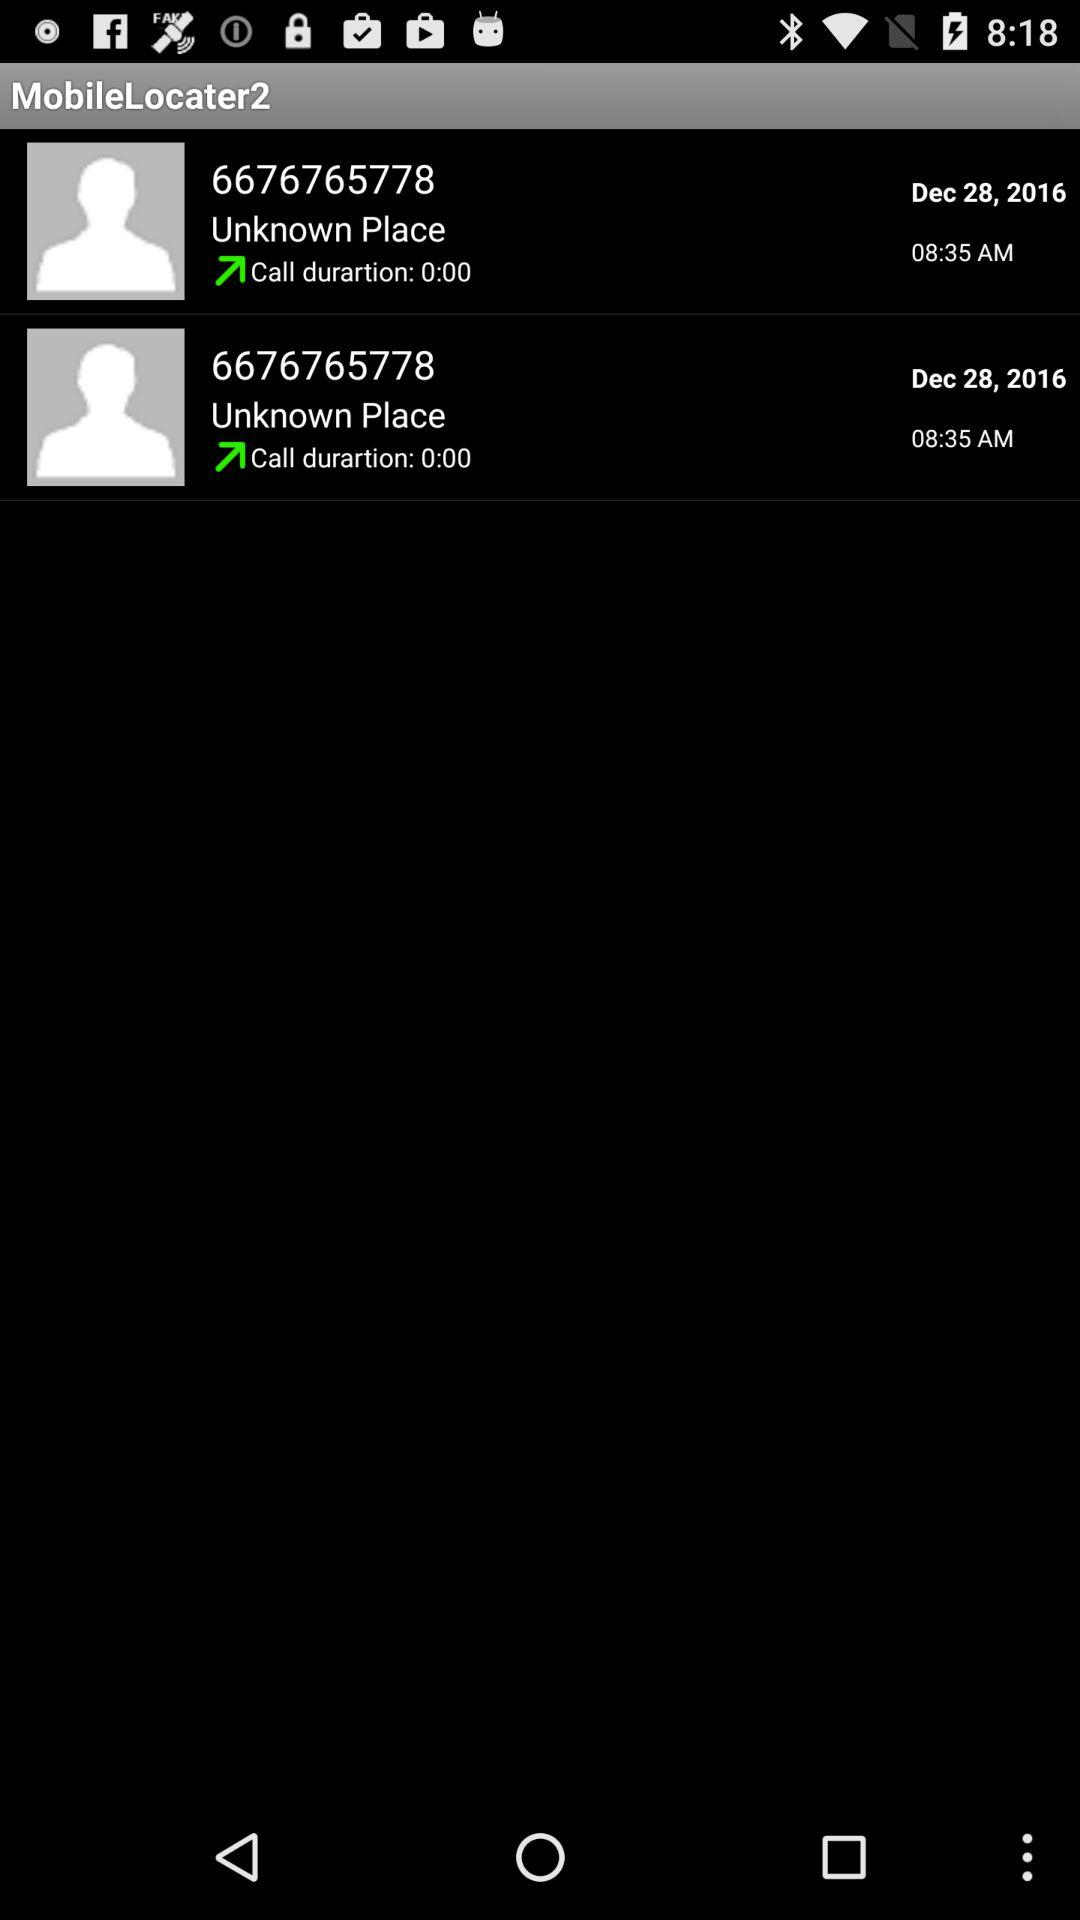What is the date of the call to 6676765778? The date is December 28, 2016. 